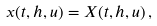Convert formula to latex. <formula><loc_0><loc_0><loc_500><loc_500>x ( t , h , u ) = X ( t , h , u ) \, ,</formula> 